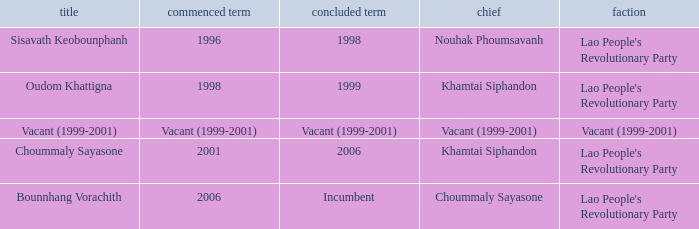What is Party, when Name is Oudom Khattigna? Lao People's Revolutionary Party. 